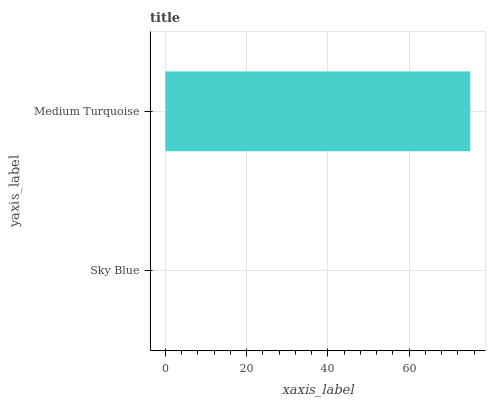Is Sky Blue the minimum?
Answer yes or no. Yes. Is Medium Turquoise the maximum?
Answer yes or no. Yes. Is Medium Turquoise the minimum?
Answer yes or no. No. Is Medium Turquoise greater than Sky Blue?
Answer yes or no. Yes. Is Sky Blue less than Medium Turquoise?
Answer yes or no. Yes. Is Sky Blue greater than Medium Turquoise?
Answer yes or no. No. Is Medium Turquoise less than Sky Blue?
Answer yes or no. No. Is Medium Turquoise the high median?
Answer yes or no. Yes. Is Sky Blue the low median?
Answer yes or no. Yes. Is Sky Blue the high median?
Answer yes or no. No. Is Medium Turquoise the low median?
Answer yes or no. No. 